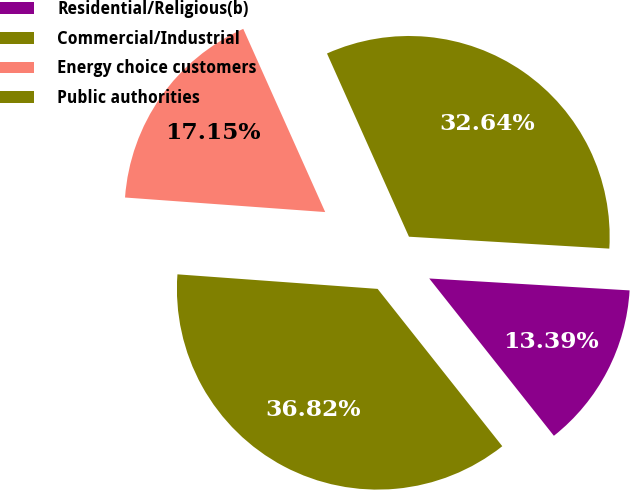<chart> <loc_0><loc_0><loc_500><loc_500><pie_chart><fcel>Residential/Religious(b)<fcel>Commercial/Industrial<fcel>Energy choice customers<fcel>Public authorities<nl><fcel>13.39%<fcel>32.64%<fcel>17.15%<fcel>36.82%<nl></chart> 